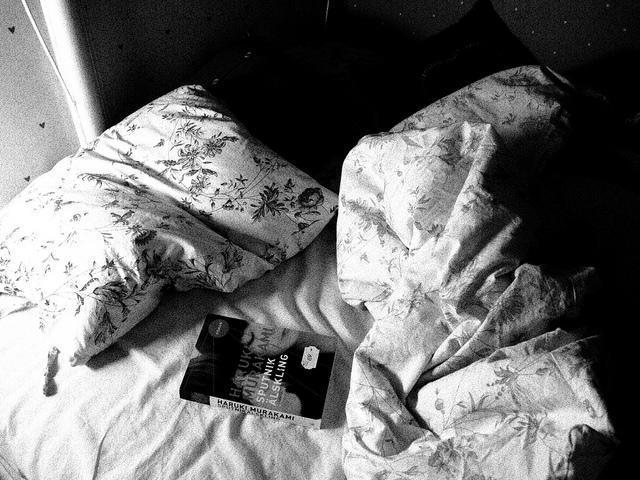How many books are in the picture?
Give a very brief answer. 1. 